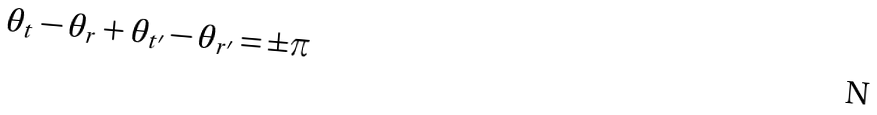<formula> <loc_0><loc_0><loc_500><loc_500>\theta _ { t } - \theta _ { r } + \theta _ { t ^ { \prime } } - \theta _ { r ^ { \prime } } = \pm \pi</formula> 